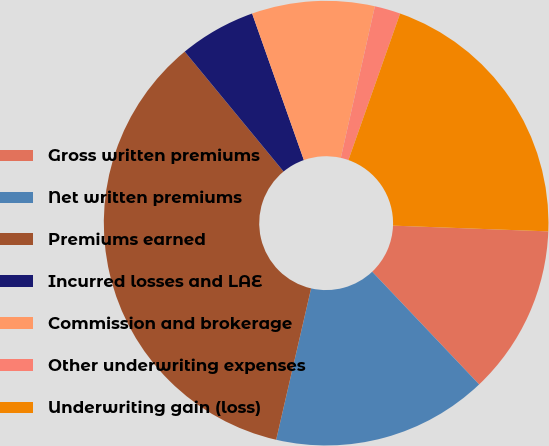Convert chart to OTSL. <chart><loc_0><loc_0><loc_500><loc_500><pie_chart><fcel>Gross written premiums<fcel>Net written premiums<fcel>Premiums earned<fcel>Incurred losses and LAE<fcel>Commission and brokerage<fcel>Other underwriting expenses<fcel>Underwriting gain (loss)<nl><fcel>12.33%<fcel>15.69%<fcel>35.42%<fcel>5.57%<fcel>8.92%<fcel>1.88%<fcel>20.19%<nl></chart> 